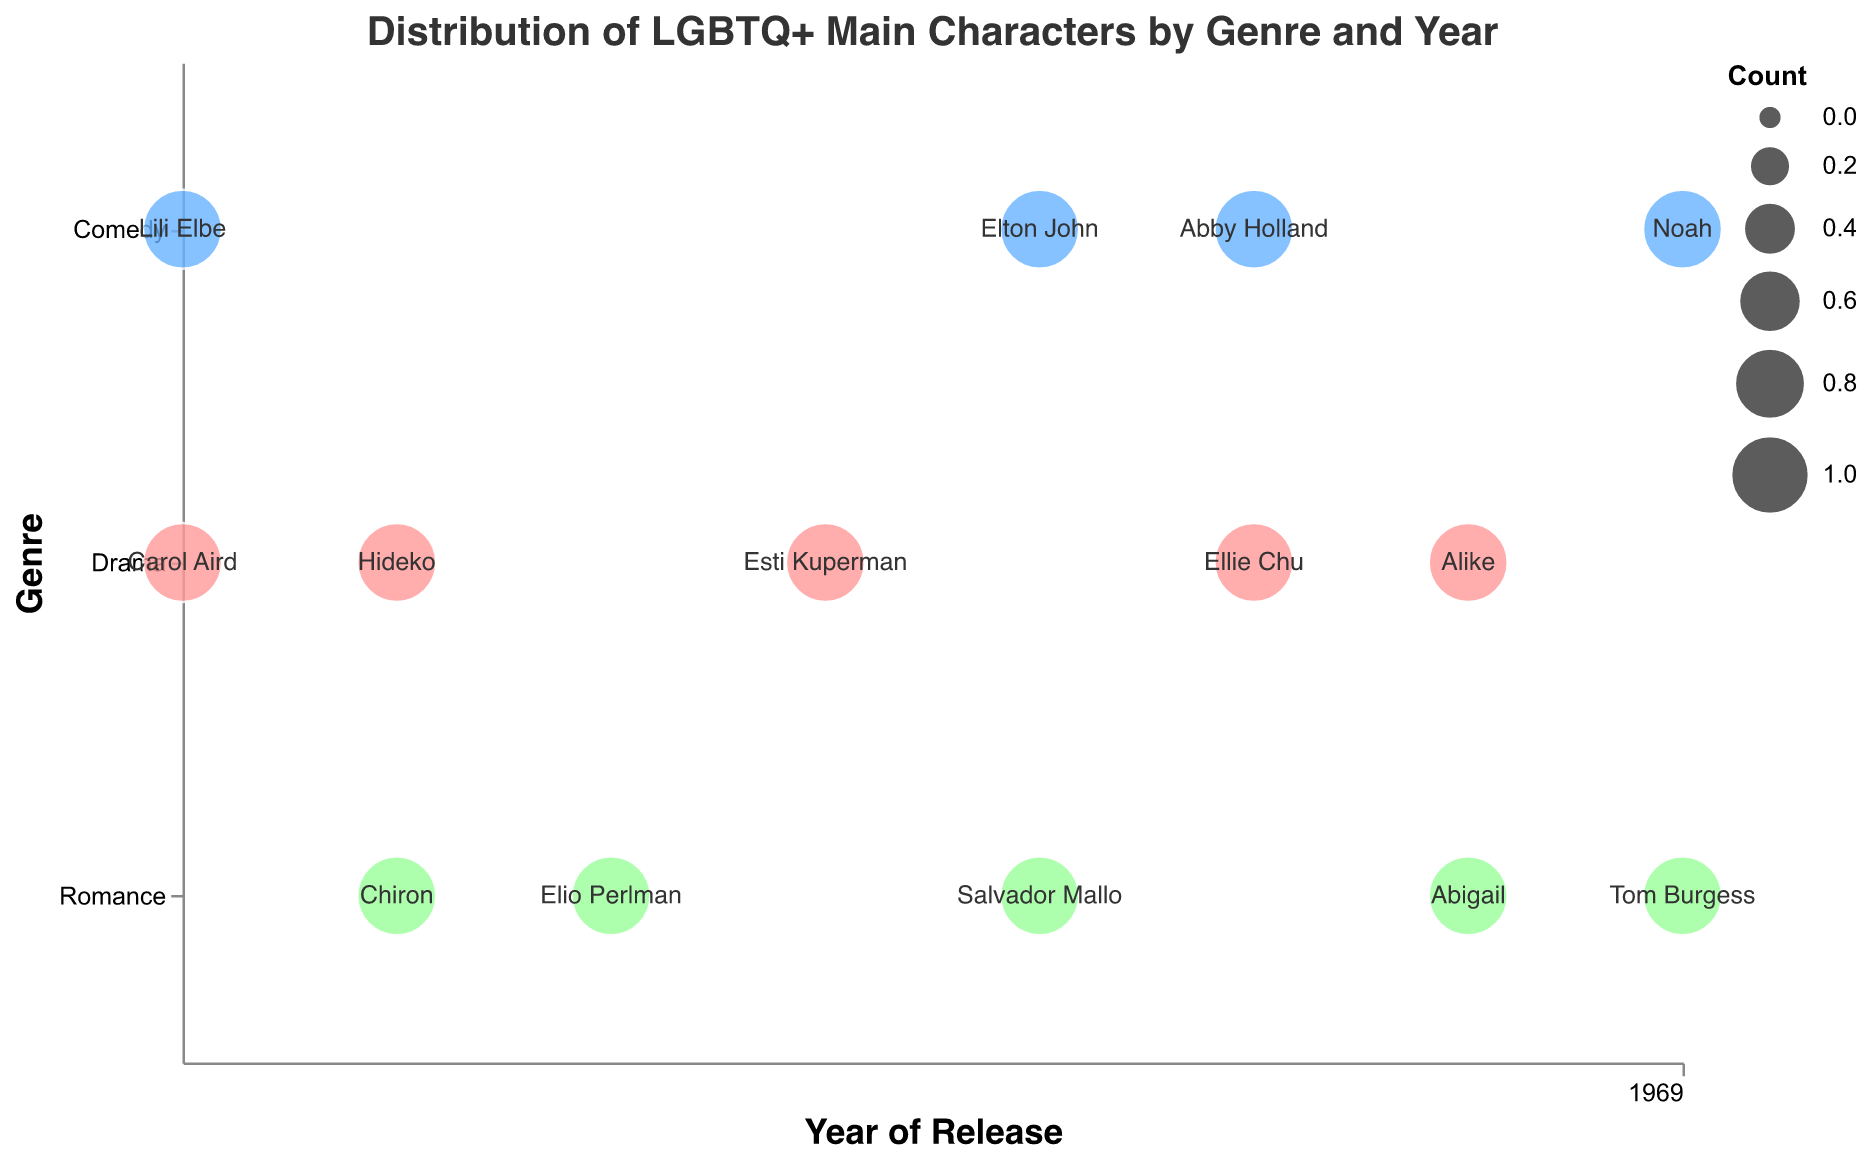How many films with LGBTQ+ main characters are represented in the plot? Count the total number of data points (bubbles) in the plot. There are 14 bubbles, each representing a film with an LGBTQ+ main character.
Answer: 14 Which genre has the most films with LGBTQ+ main characters in 2020? Locate the year 2020 on the x-axis and count the number of bubbles for each genre (Drama, Comedy, Romance). Drama and Comedy each have one film.
Answer: Drama, Comedy What is the total number of Drama films with LGBTQ+ main characters from 2015 to 2022? Identify the Drama bubbles across the years and sum them up. There is one Drama film each year from 2015, 2016, 2018, 2020, and 2021, totaling 5.
Answer: 5 Which film features the LGBTQ+ main character "Elio Perlman"? Look at the text labels inside the bubbles and find "Elio Perlman." It corresponds to the film "Call Me by Your Name."
Answer: Call Me by Your Name Are there any years with films in all three genres (Drama, Comedy, Romance)? Check each year for the presence of bubbles from all three genres. No single year has films in all three genres.
Answer: No Compare the number of Romance films with LGBTQ+ main characters between 2016 and 2022. Which year has more? Count the Romance bubbles in 2016 (1 film, "Moonlight") and 2022 (1 film, "My Policeman"). Both years have one Romance film each.
Answer: Equal What are the colors representing each genre? Observe the bubble colors and their corresponding genre labels. Drama is light red, Comedy is light blue, and Romance is light green.
Answer: Drama: light red, Comedy: light blue, Romance: light green Identify the film with the LGBTQ+ main character named "Chiron." Check the text labels inside the bubbles for "Chiron." The film is "Moonlight."
Answer: Moonlight Which genres feature LGBTQ+ main characters in 2019? Look at the bubbles for 2019 and identify their genre colors. There are Comedy (Rocketman) and Romance (Pain and Glory) films.
Answer: Comedy, Romance How many Romance films with LGBTQ+ main characters were released from 2017 to 2022? Count the number of Romance bubbles between 2017 and 2022: "Call Me by Your Name" (2017), "The World to Come" (2021), "My Policeman" (2022), totaling 3.
Answer: 3 